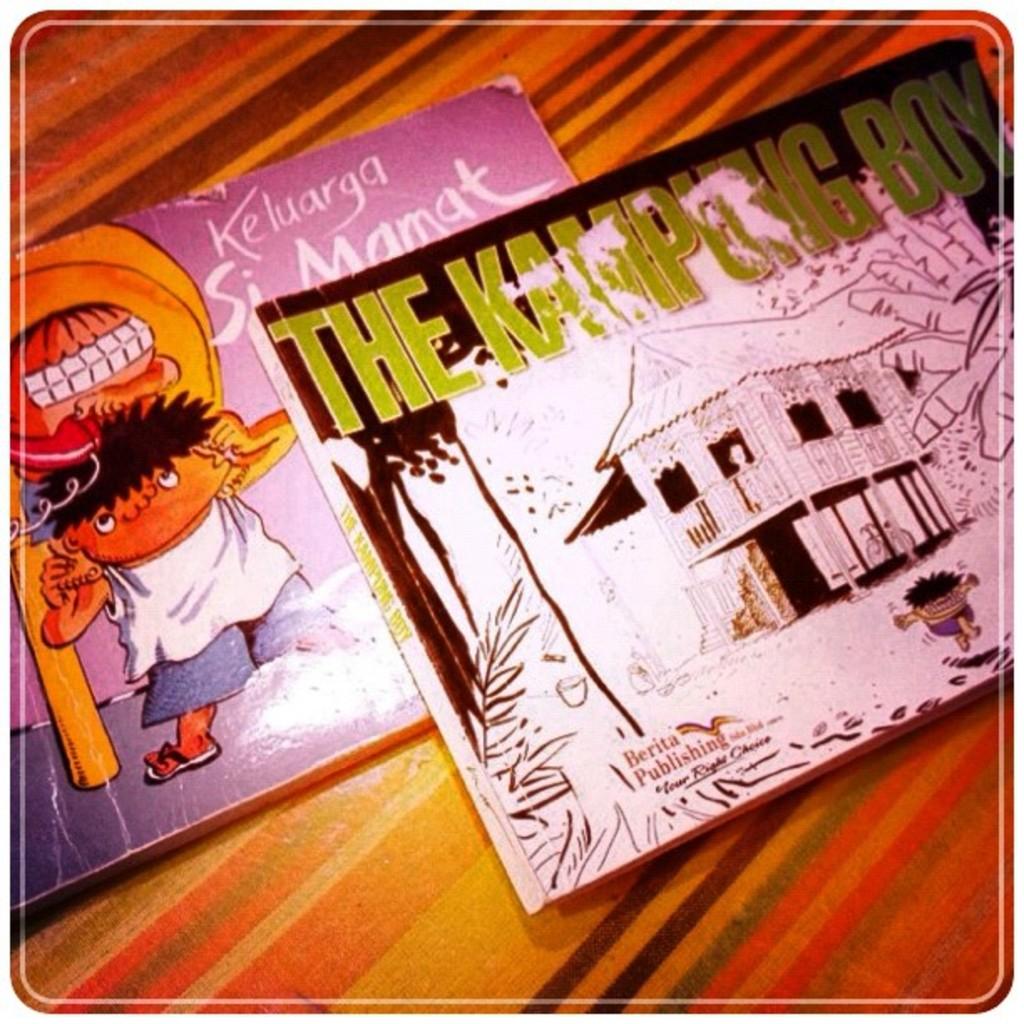Are the books for kids ?
Your response must be concise. Yes. What is the title of the book in front?
Offer a very short reply. The kampung boy. 